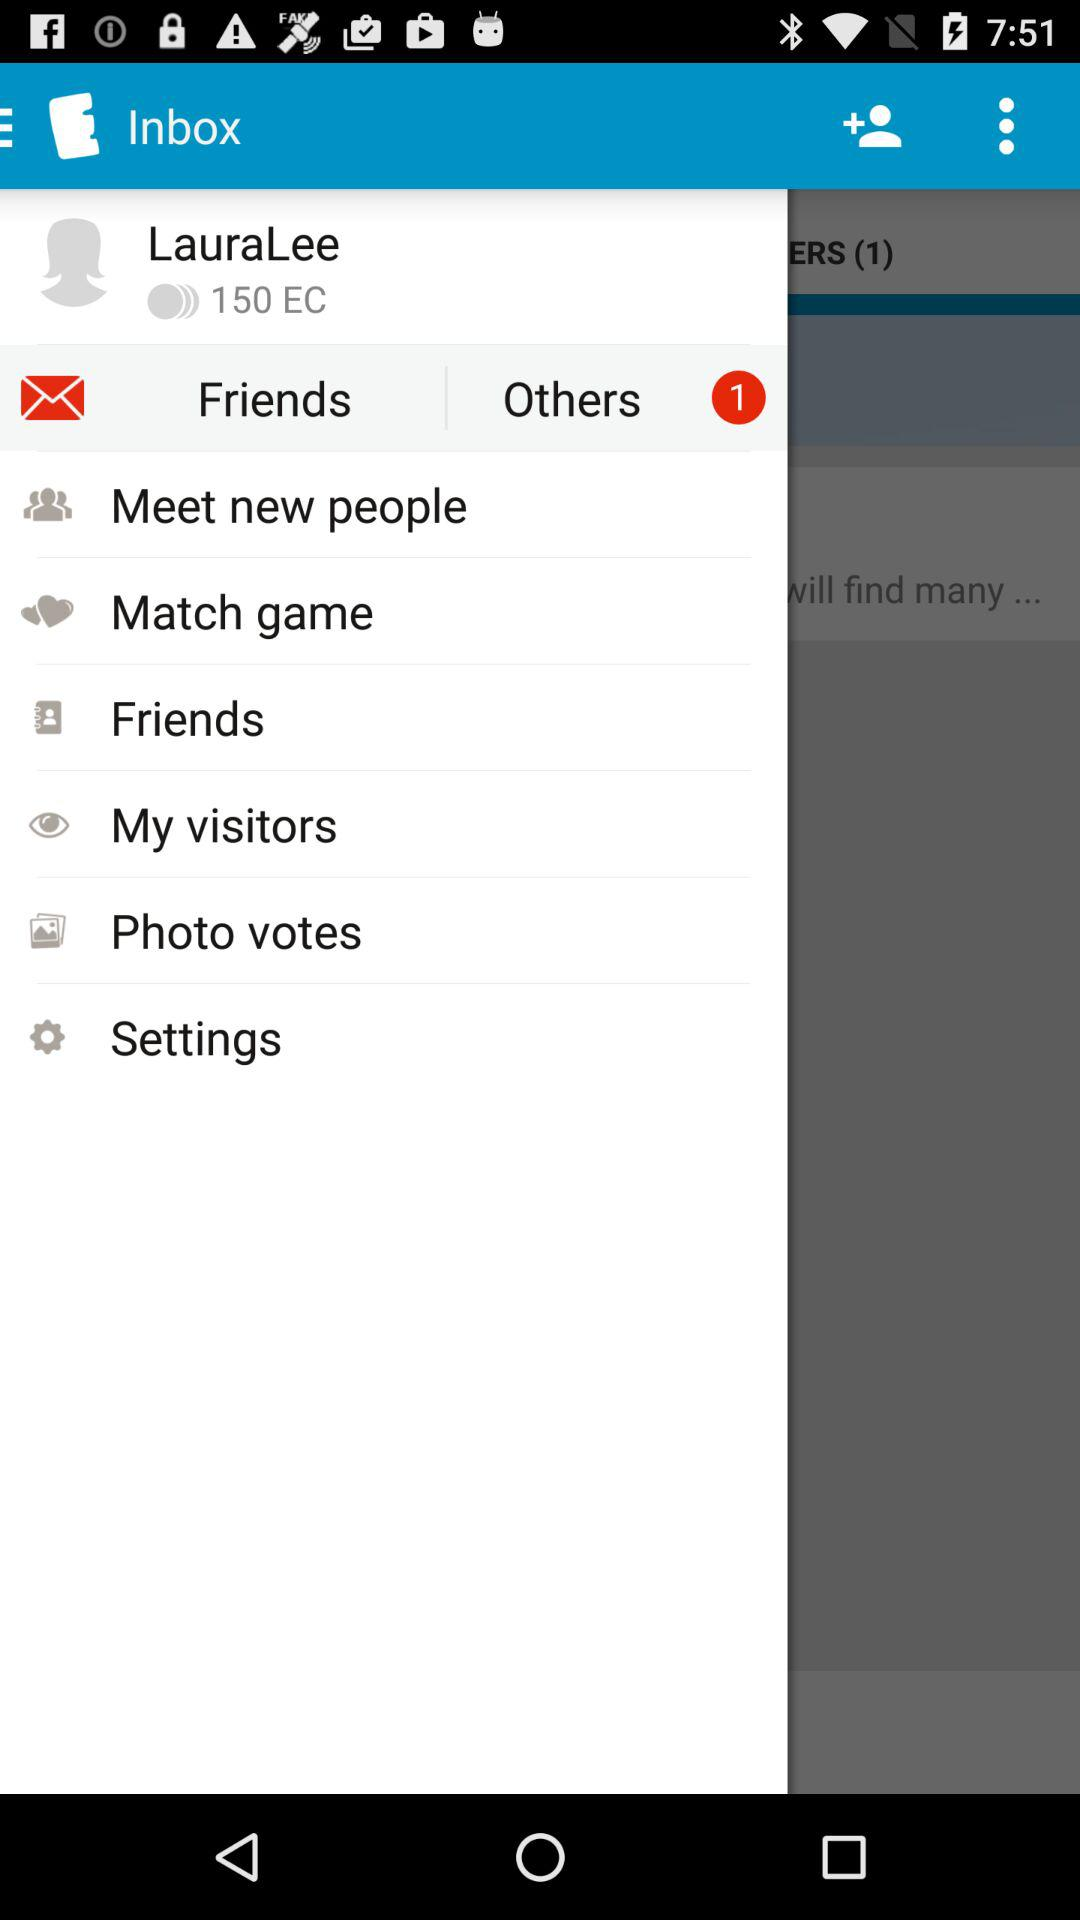How many notifications are there in "Settings"?
When the provided information is insufficient, respond with <no answer>. <no answer> 